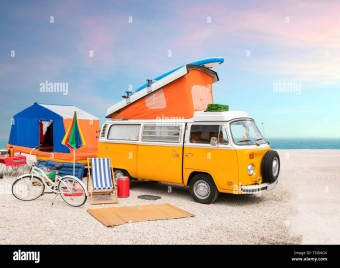What additional items can be seen around the camper van that suggest a leisure activity? Around the camper van, there are several items suggesting leisure activities, including a surfboard on top of the van, bicycles next to it, and a colorful beach umbrella, indicating a setup for a beach outing or a similar recreational trip. 